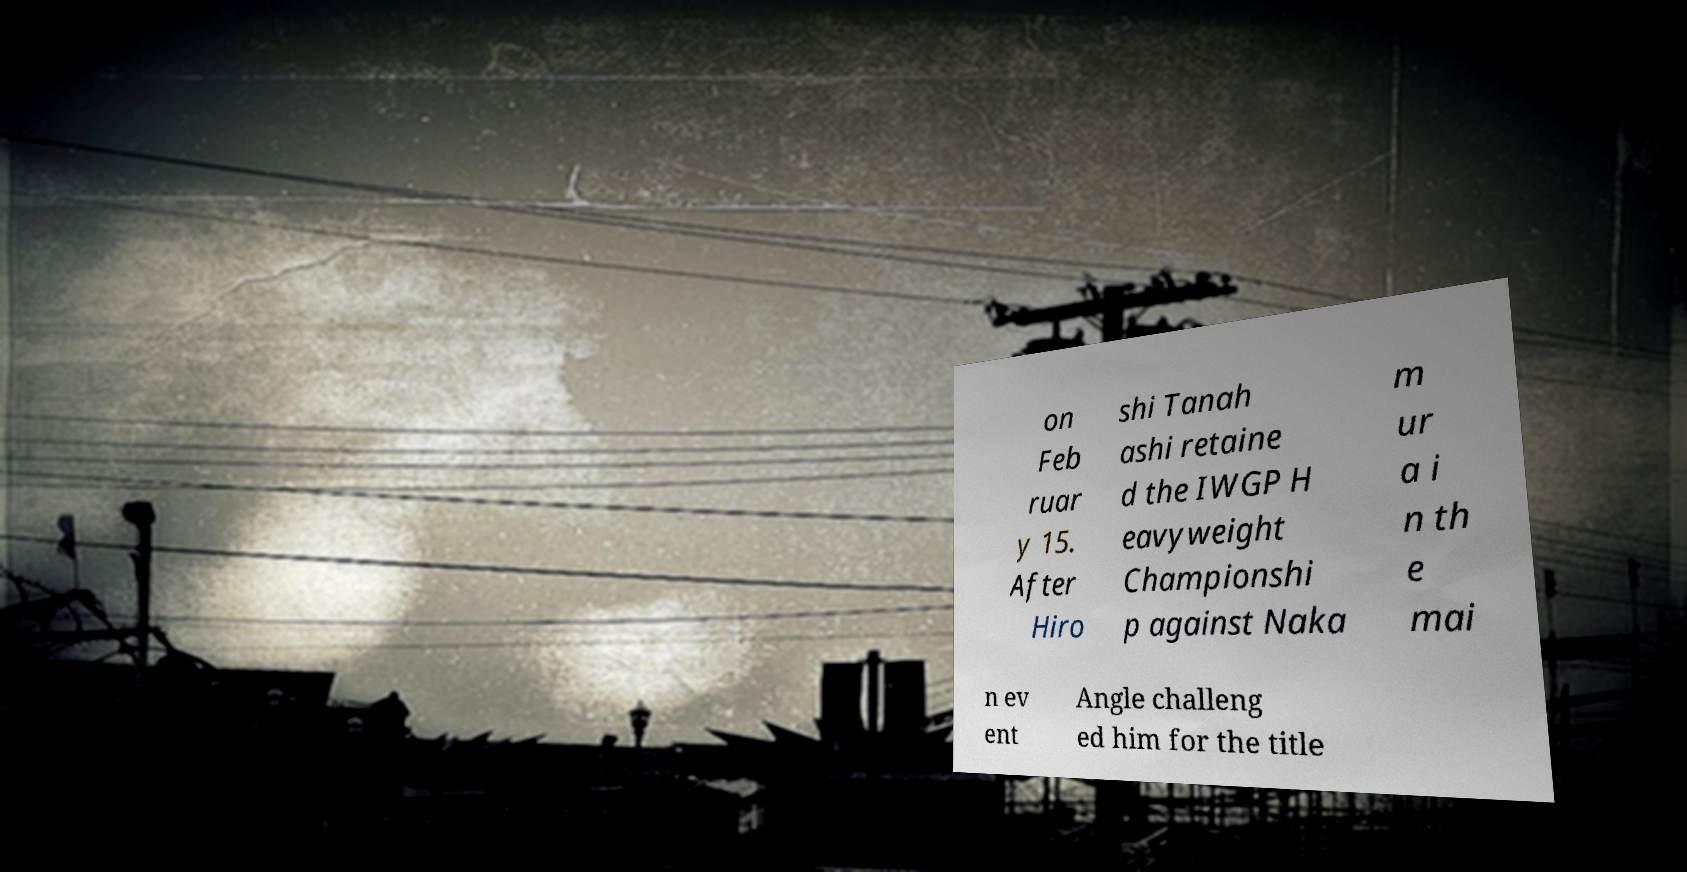Can you accurately transcribe the text from the provided image for me? on Feb ruar y 15. After Hiro shi Tanah ashi retaine d the IWGP H eavyweight Championshi p against Naka m ur a i n th e mai n ev ent Angle challeng ed him for the title 